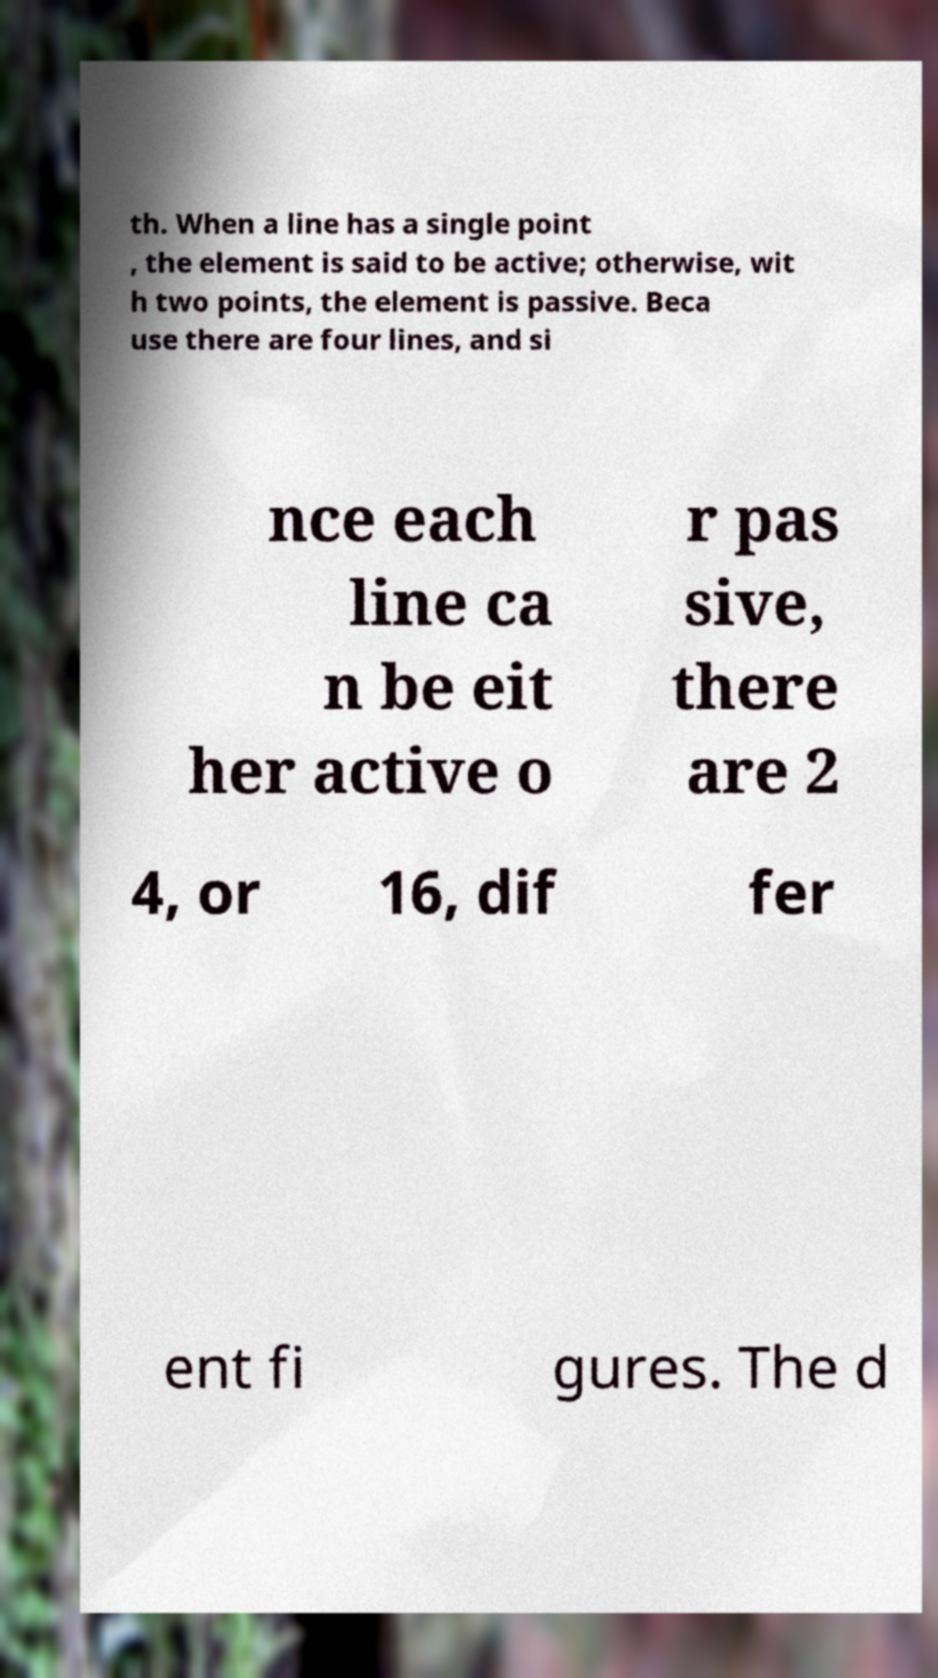Can you accurately transcribe the text from the provided image for me? th. When a line has a single point , the element is said to be active; otherwise, wit h two points, the element is passive. Beca use there are four lines, and si nce each line ca n be eit her active o r pas sive, there are 2 4, or 16, dif fer ent fi gures. The d 